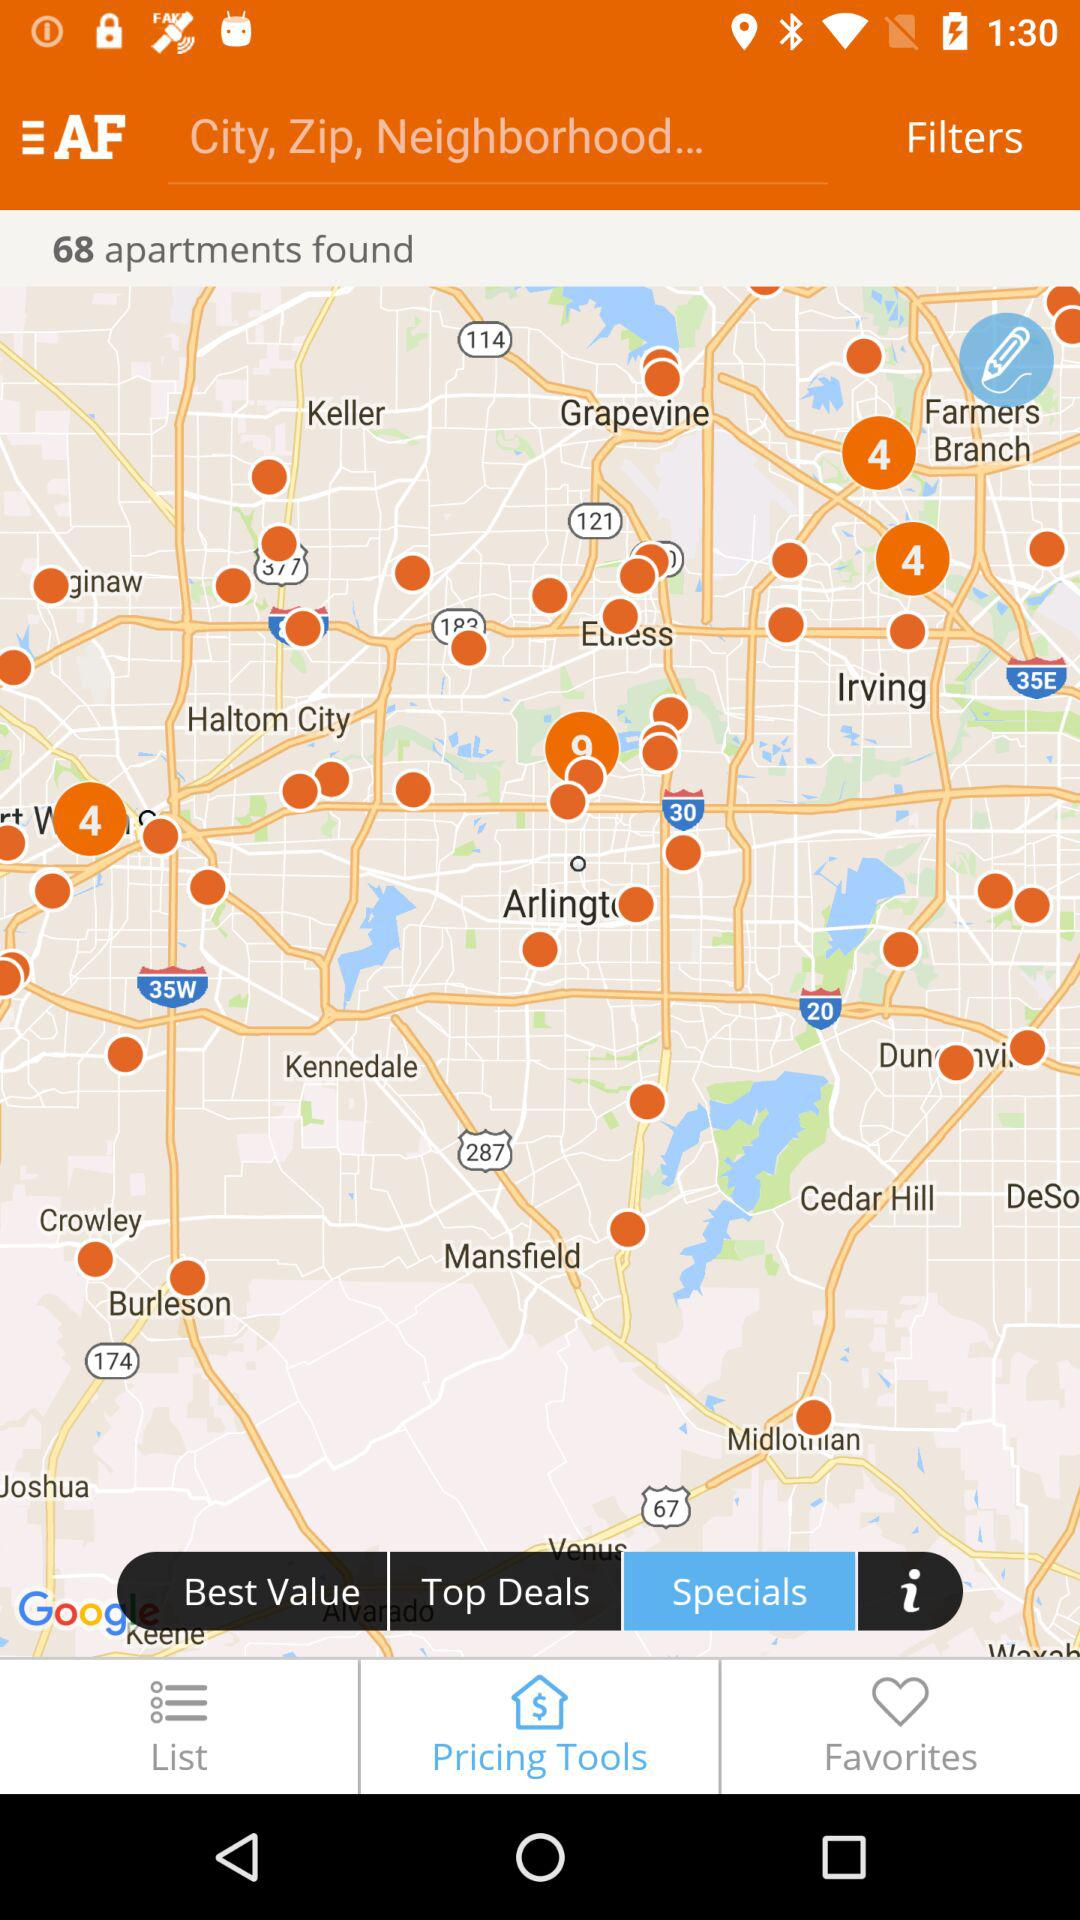How many apartments were found? The number of found apartments is 68. 